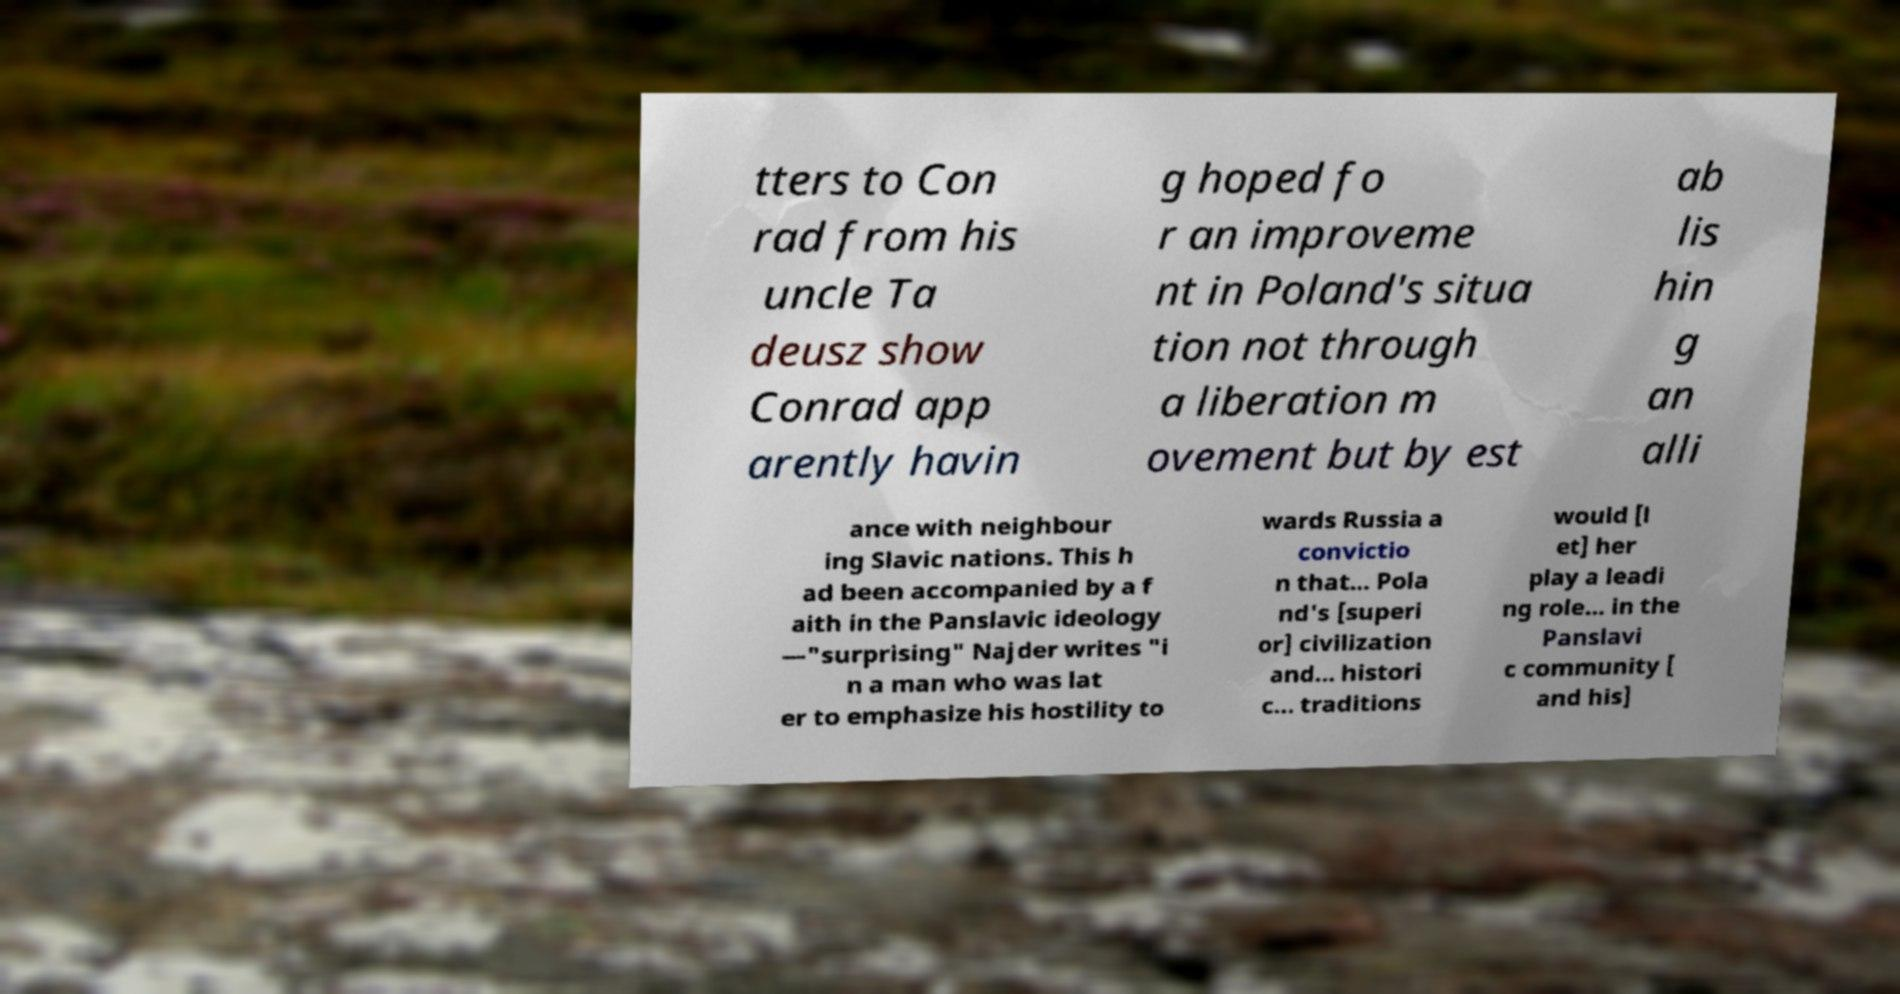Please read and relay the text visible in this image. What does it say? tters to Con rad from his uncle Ta deusz show Conrad app arently havin g hoped fo r an improveme nt in Poland's situa tion not through a liberation m ovement but by est ab lis hin g an alli ance with neighbour ing Slavic nations. This h ad been accompanied by a f aith in the Panslavic ideology —"surprising" Najder writes "i n a man who was lat er to emphasize his hostility to wards Russia a convictio n that... Pola nd's [superi or] civilization and... histori c... traditions would [l et] her play a leadi ng role... in the Panslavi c community [ and his] 